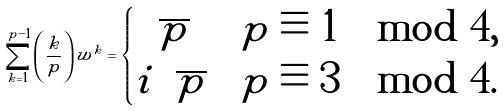<formula> <loc_0><loc_0><loc_500><loc_500>\sum _ { k = 1 } ^ { p - 1 } \left ( \frac { k } { p } \right ) w ^ { k } = \begin{cases} \sqrt { p } & p \equiv 1 \mod 4 , \\ i \sqrt { p } & p \equiv 3 \mod 4 . \end{cases}</formula> 